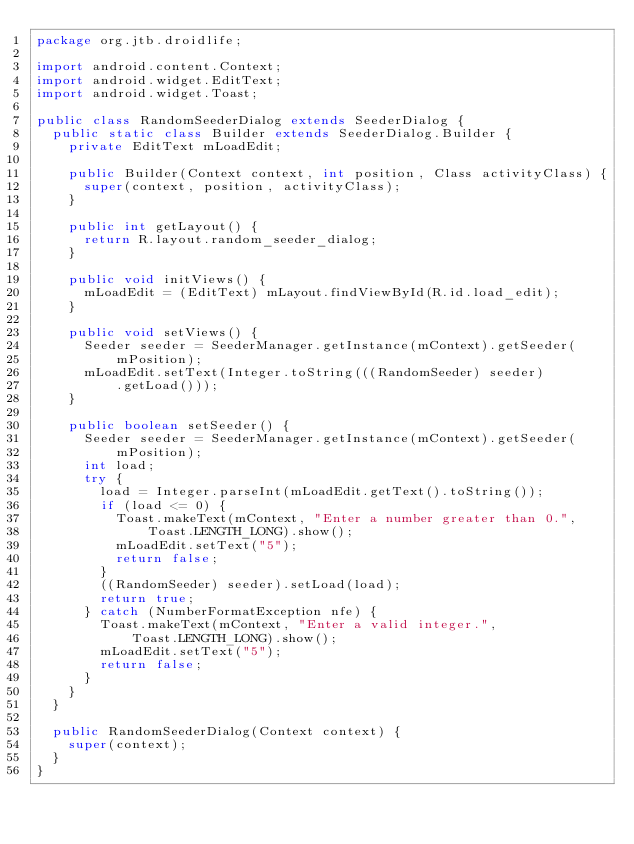Convert code to text. <code><loc_0><loc_0><loc_500><loc_500><_Java_>package org.jtb.droidlife;

import android.content.Context;
import android.widget.EditText;
import android.widget.Toast;

public class RandomSeederDialog extends SeederDialog {
	public static class Builder extends SeederDialog.Builder {
		private EditText mLoadEdit;

		public Builder(Context context, int position, Class activityClass) {
			super(context, position, activityClass);
		}

		public int getLayout() {
			return R.layout.random_seeder_dialog;
		}

		public void initViews() {
			mLoadEdit = (EditText) mLayout.findViewById(R.id.load_edit);
		}

		public void setViews() {
			Seeder seeder = SeederManager.getInstance(mContext).getSeeder(
					mPosition);
			mLoadEdit.setText(Integer.toString(((RandomSeeder) seeder)
					.getLoad()));
		}

		public boolean setSeeder() {
			Seeder seeder = SeederManager.getInstance(mContext).getSeeder(
					mPosition);
			int load;
			try {
				load = Integer.parseInt(mLoadEdit.getText().toString());
				if (load <= 0) {
					Toast.makeText(mContext, "Enter a number greater than 0.",
							Toast.LENGTH_LONG).show();
					mLoadEdit.setText("5");					
					return false;
				}
				((RandomSeeder) seeder).setLoad(load);
				return true;
			} catch (NumberFormatException nfe) {
				Toast.makeText(mContext, "Enter a valid integer.",
						Toast.LENGTH_LONG).show();
				mLoadEdit.setText("5");
				return false;
			}
		}
	}

	public RandomSeederDialog(Context context) {
		super(context);
	}
}
</code> 